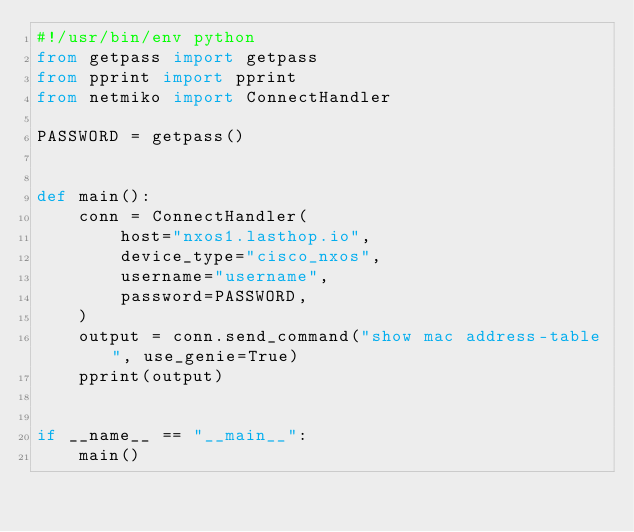Convert code to text. <code><loc_0><loc_0><loc_500><loc_500><_Python_>#!/usr/bin/env python
from getpass import getpass
from pprint import pprint
from netmiko import ConnectHandler

PASSWORD = getpass()


def main():
    conn = ConnectHandler(
        host="nxos1.lasthop.io",
        device_type="cisco_nxos",
        username="username",
        password=PASSWORD,
    )
    output = conn.send_command("show mac address-table", use_genie=True)
    pprint(output)


if __name__ == "__main__":
    main()
</code> 